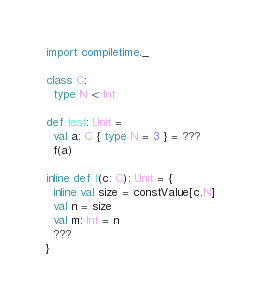Convert code to text. <code><loc_0><loc_0><loc_500><loc_500><_Scala_>import compiletime._

class C:
  type N <: Int

def test: Unit =
  val a: C { type N = 3 } = ???
  f(a)

inline def f(c: C): Unit = {
  inline val size = constValue[c.N]
  val n = size
  val m: Int = n
  ???
}
</code> 